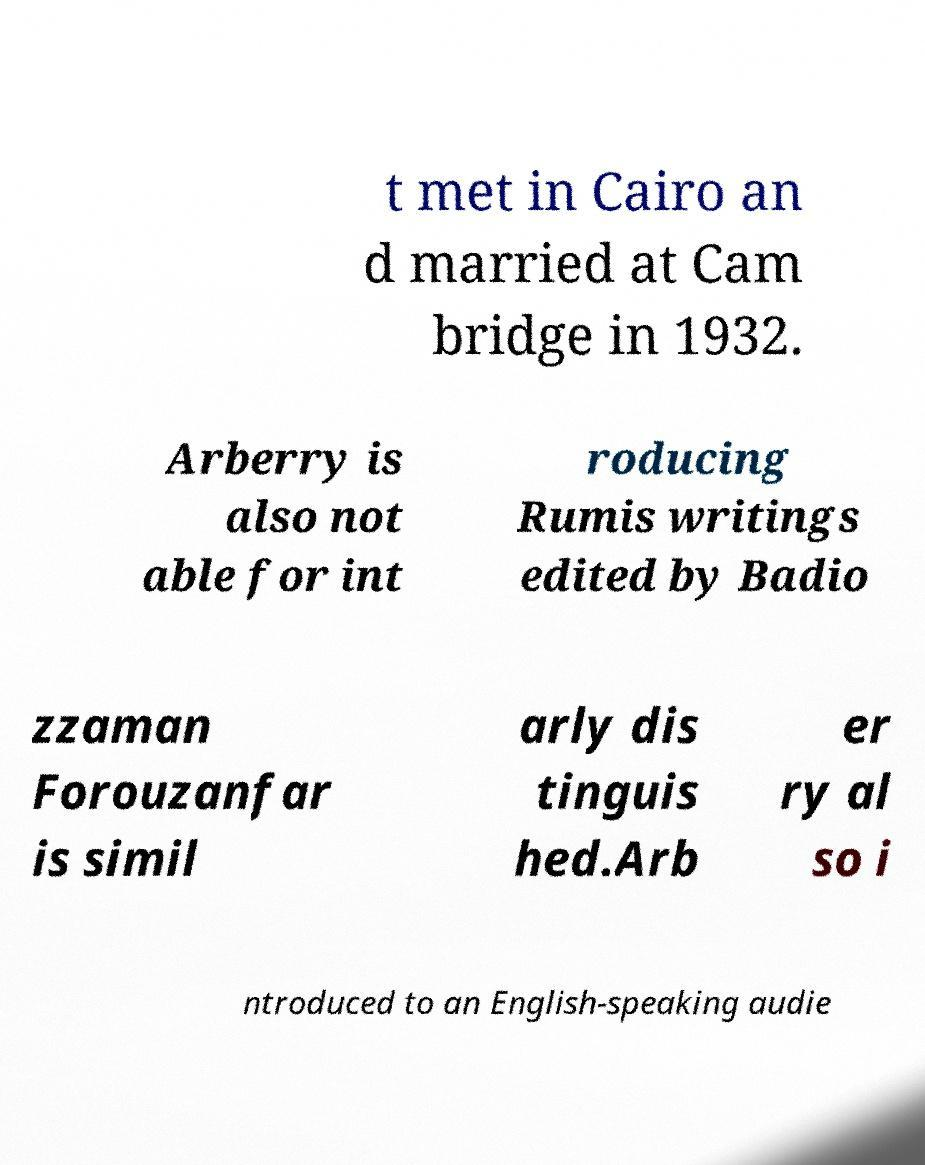Please identify and transcribe the text found in this image. t met in Cairo an d married at Cam bridge in 1932. Arberry is also not able for int roducing Rumis writings edited by Badio zzaman Forouzanfar is simil arly dis tinguis hed.Arb er ry al so i ntroduced to an English-speaking audie 